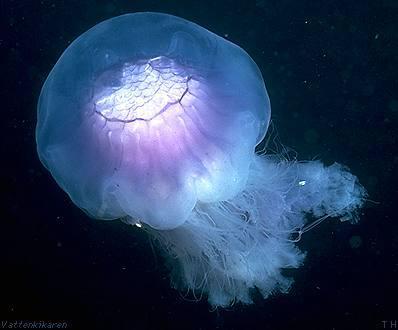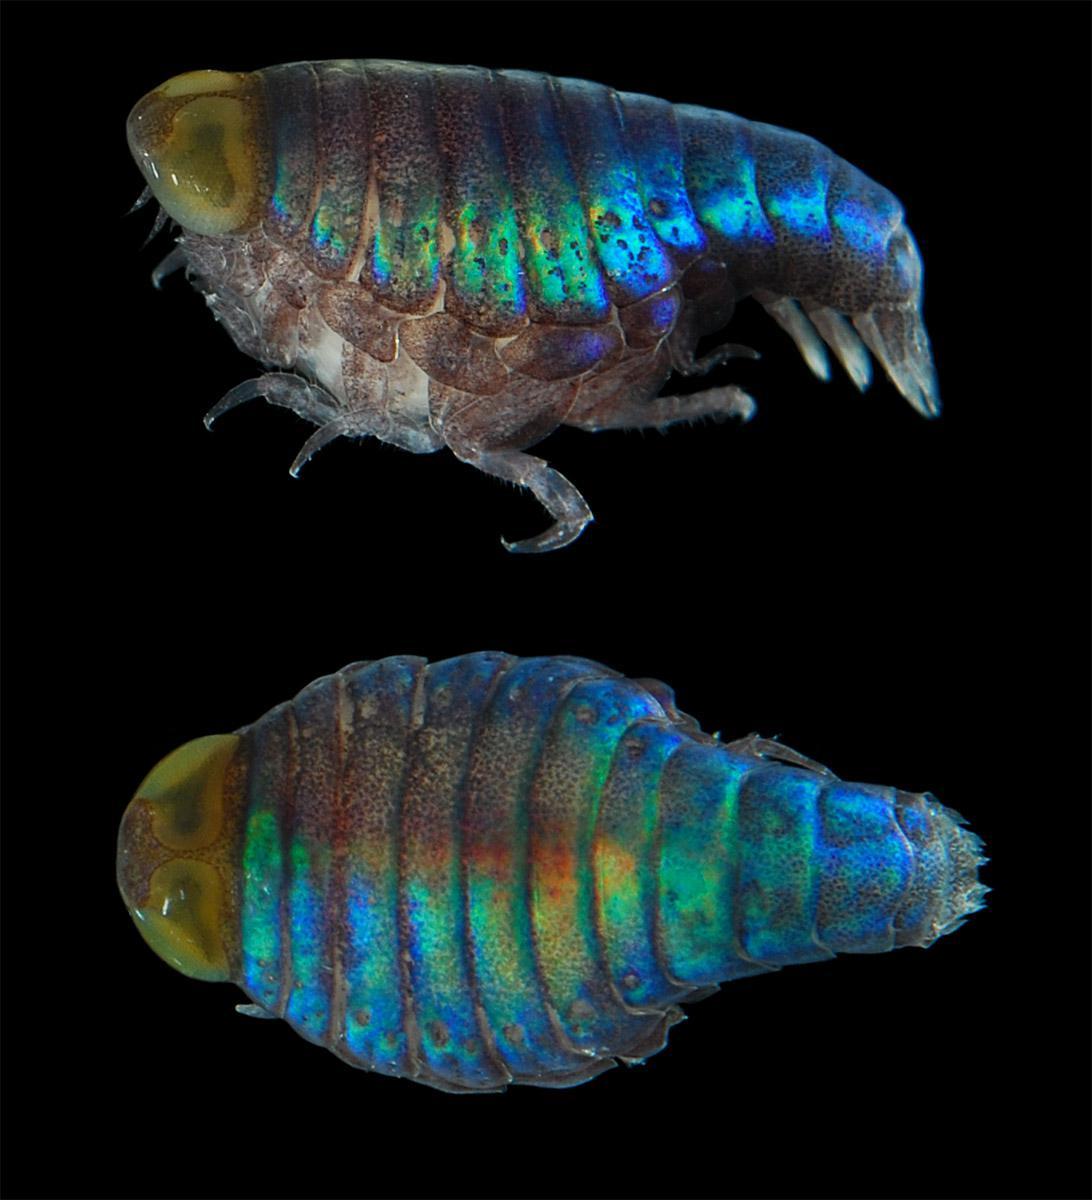The first image is the image on the left, the second image is the image on the right. Given the left and right images, does the statement "All the organisms have long tentacles." hold true? Answer yes or no. No. The first image is the image on the left, the second image is the image on the right. Examine the images to the left and right. Is the description "Each image shows one jellyfish, and one image shows a translucent blue jellyfish with lavender and cream colored interior parts showing, and stringy tentacles trailing nearly straight downward." accurate? Answer yes or no. No. 